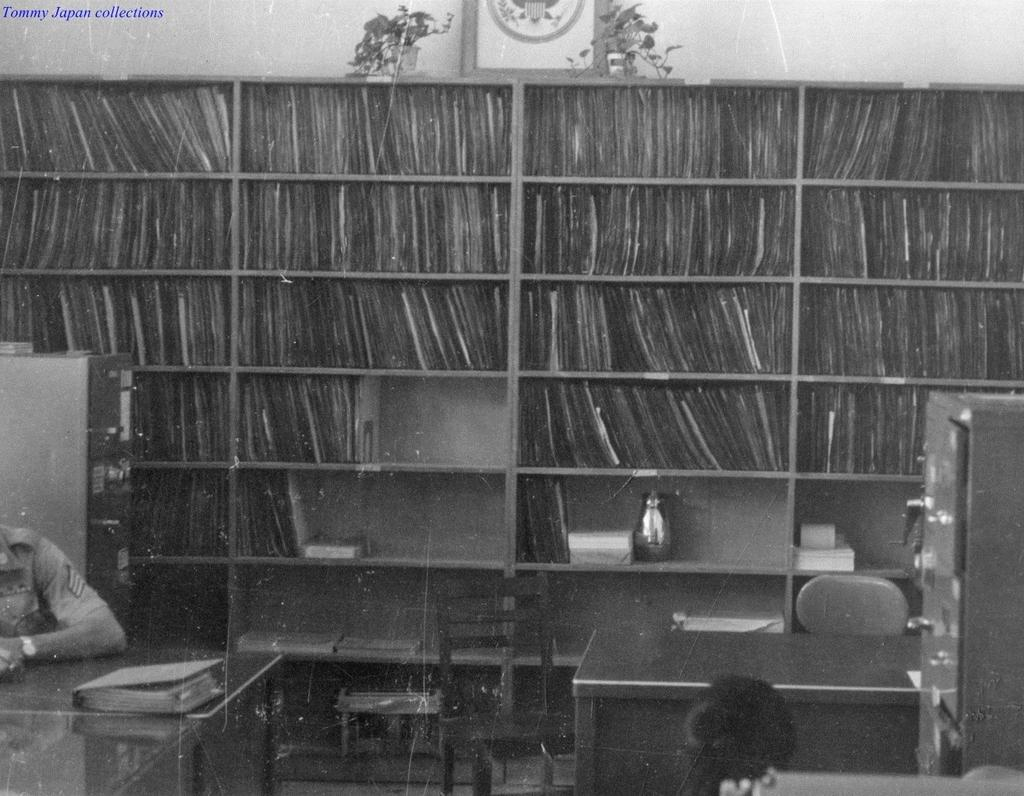What is the main subject of the image? There is a person in the image. What objects are present on the tables in the image? There are tables with a book on them in the image. Where are the lockers located in the image? The lockers are in the left and corner of the image. What type of furniture is present in the image? There are chairs in the image. What can be seen in the background of the image? There is a bookshelf, a frame, and potted plants in the background. What activity is the person's eyes performing in the image? The image does not show the person's eyes, so it is not possible to determine what activity they might be performing. 